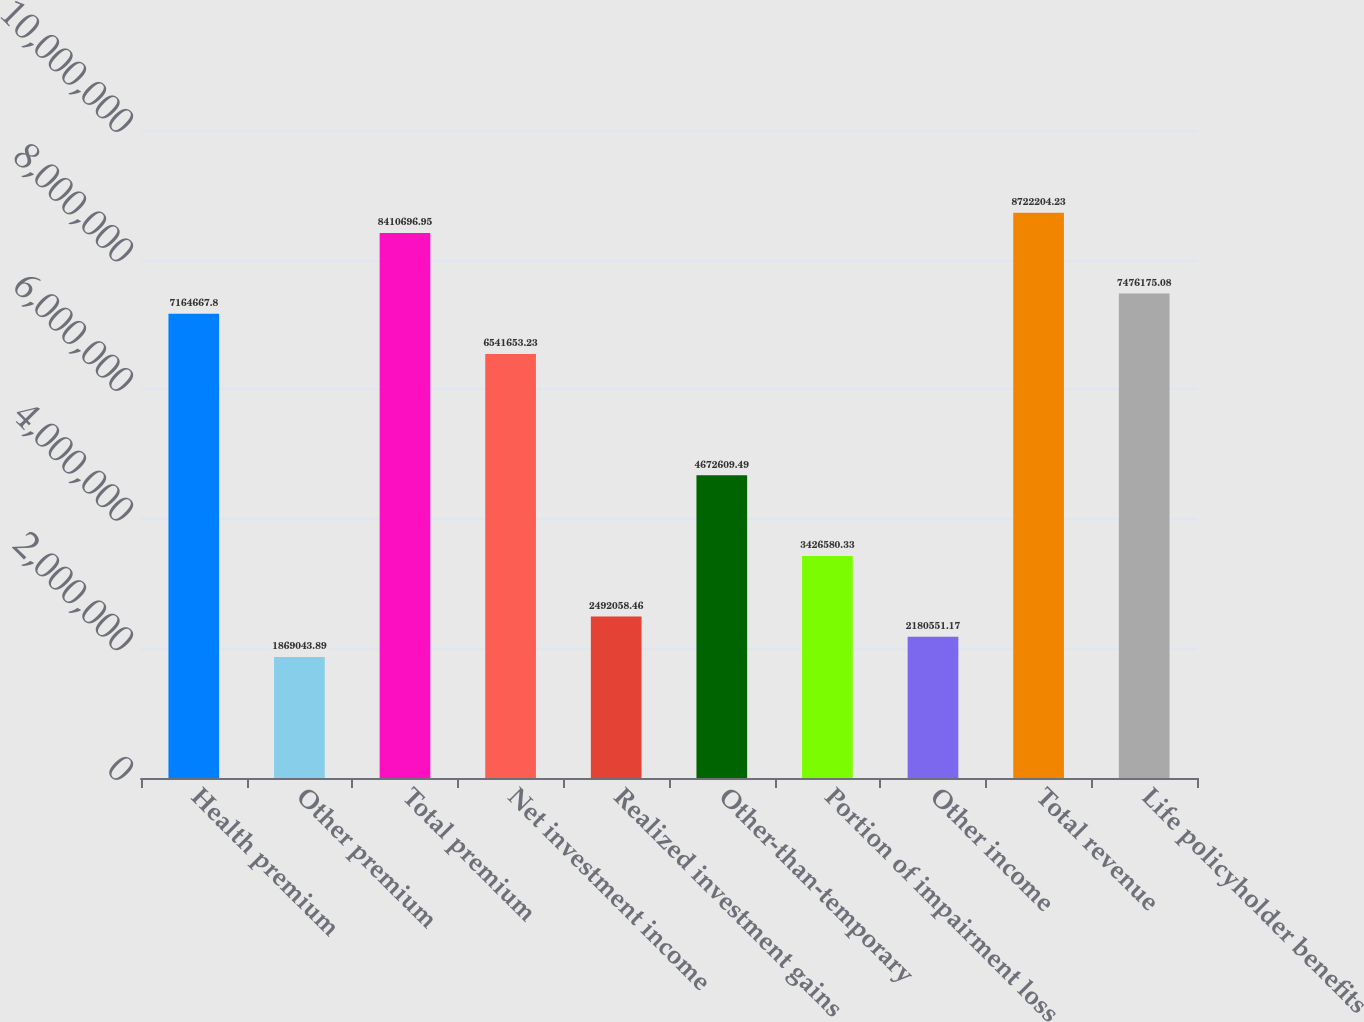<chart> <loc_0><loc_0><loc_500><loc_500><bar_chart><fcel>Health premium<fcel>Other premium<fcel>Total premium<fcel>Net investment income<fcel>Realized investment gains<fcel>Other-than-temporary<fcel>Portion of impairment loss<fcel>Other income<fcel>Total revenue<fcel>Life policyholder benefits<nl><fcel>7.16467e+06<fcel>1.86904e+06<fcel>8.4107e+06<fcel>6.54165e+06<fcel>2.49206e+06<fcel>4.67261e+06<fcel>3.42658e+06<fcel>2.18055e+06<fcel>8.7222e+06<fcel>7.47618e+06<nl></chart> 